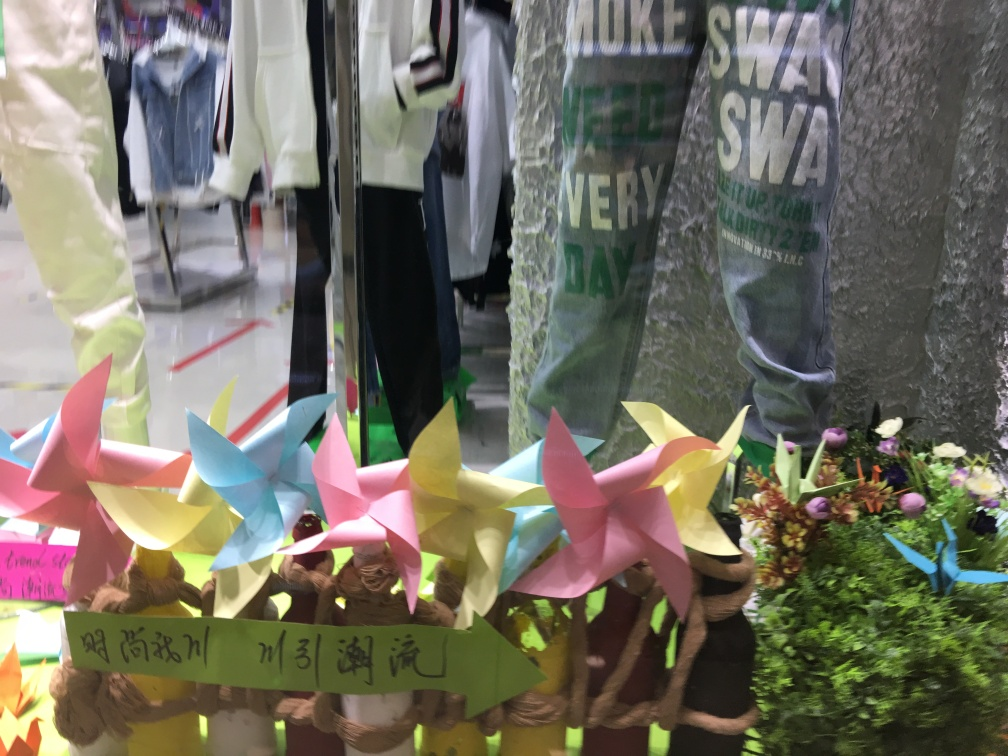What does the presence of clothes in the background tell us about the setting? The clothing items in the background suggest that this image was taken inside a clothing store or a similar retail space. The style of clothes could give us clues about the target demographic of the store or the current fashion trends it's following. 